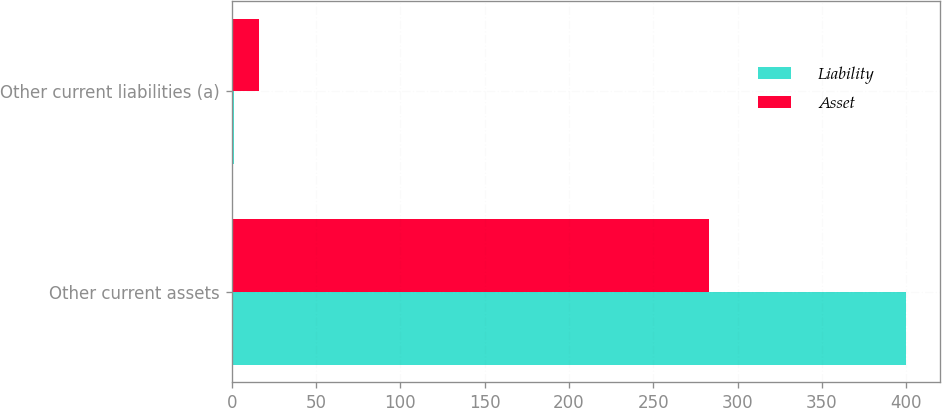Convert chart to OTSL. <chart><loc_0><loc_0><loc_500><loc_500><stacked_bar_chart><ecel><fcel>Other current assets<fcel>Other current liabilities (a)<nl><fcel>Liability<fcel>400<fcel>1<nl><fcel>Asset<fcel>283<fcel>16<nl></chart> 